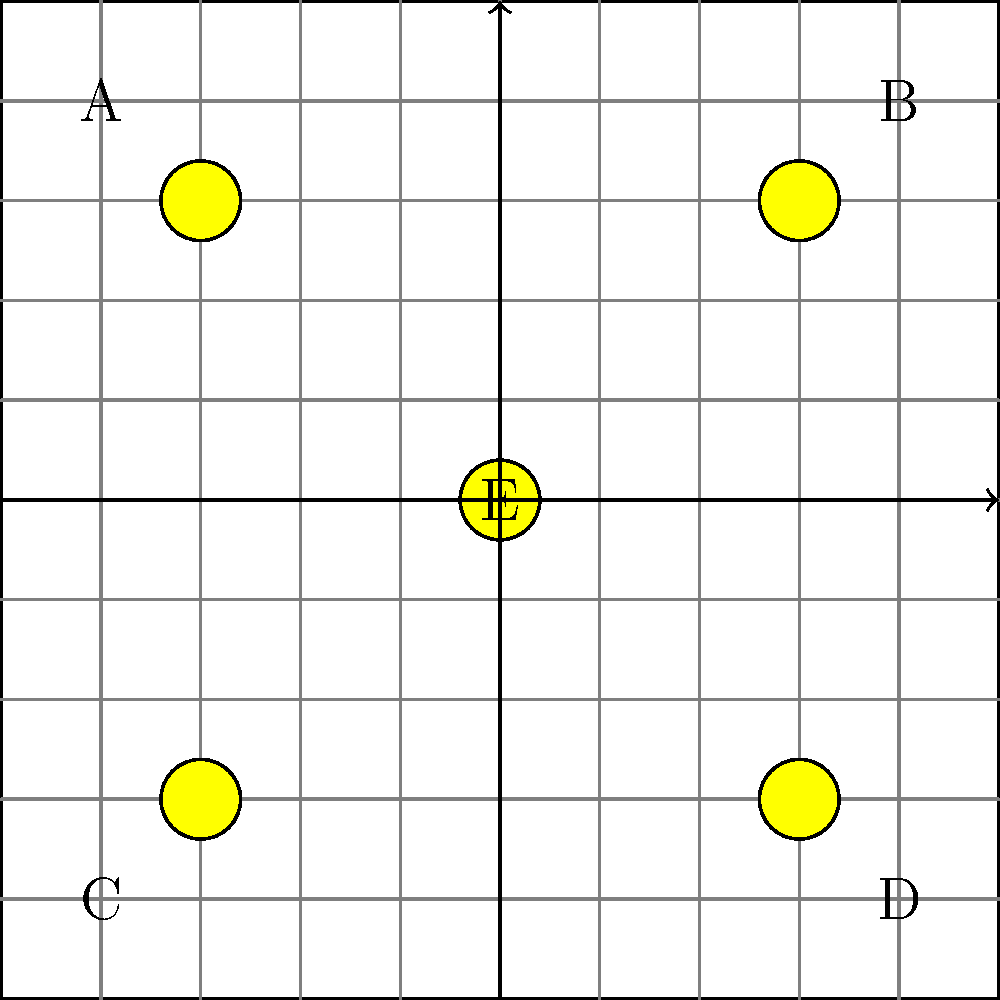In the casino floor layout shown above, slot machines are placed in areas A, B, C, D, and E. Given that the main traffic flow is along the horizontal and vertical central axes, which arrangement of these 5 slot machines would maximize player engagement while maintaining the highest house edge? Assume that machines closer to high-traffic areas have higher engagement but slightly lower house edge due to more frequent payouts. To solve this problem, we need to consider both player engagement and house edge:

1. Player engagement is higher for machines closer to high-traffic areas (central axes).
2. House edge is slightly lower for machines in high-traffic areas due to more frequent payouts.

Let's analyze each position:

- E (center): Highest engagement, lowest house edge
- A, B, C, D (corners): Lower engagement, highest house edge

To optimize both factors:

1. Place the machine with the highest house edge but lowest appeal in position E to maximize exposure.
2. Place the next two highest house edge machines in two opposite corners (e.g., A and D).
3. Place the two most appealing machines with slightly lower house edges in the remaining corners (e.g., B and C).

This arrangement ensures that:
- The least appealing machine gets maximum exposure in the center.
- The two moderately appealing machines are placed diagonally, creating a balanced layout.
- The two most appealing machines are placed in corners, encouraging players to explore the casino floor.

This strategy maximizes overall engagement while maintaining a high average house edge across all machines.
Answer: E: highest edge; A, D: high edge; B, C: lower edge, high appeal 